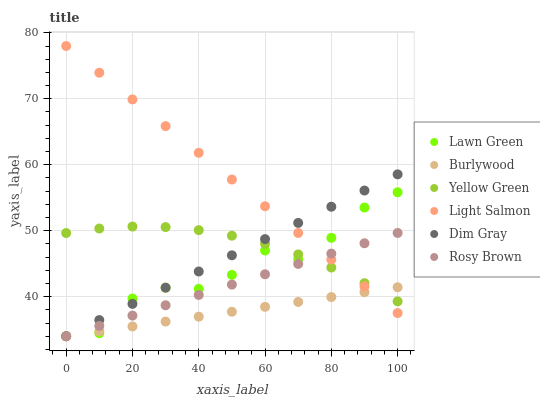Does Burlywood have the minimum area under the curve?
Answer yes or no. Yes. Does Light Salmon have the maximum area under the curve?
Answer yes or no. Yes. Does Dim Gray have the minimum area under the curve?
Answer yes or no. No. Does Dim Gray have the maximum area under the curve?
Answer yes or no. No. Is Dim Gray the smoothest?
Answer yes or no. Yes. Is Lawn Green the roughest?
Answer yes or no. Yes. Is Light Salmon the smoothest?
Answer yes or no. No. Is Light Salmon the roughest?
Answer yes or no. No. Does Lawn Green have the lowest value?
Answer yes or no. Yes. Does Light Salmon have the lowest value?
Answer yes or no. No. Does Light Salmon have the highest value?
Answer yes or no. Yes. Does Dim Gray have the highest value?
Answer yes or no. No. Does Burlywood intersect Rosy Brown?
Answer yes or no. Yes. Is Burlywood less than Rosy Brown?
Answer yes or no. No. Is Burlywood greater than Rosy Brown?
Answer yes or no. No. 